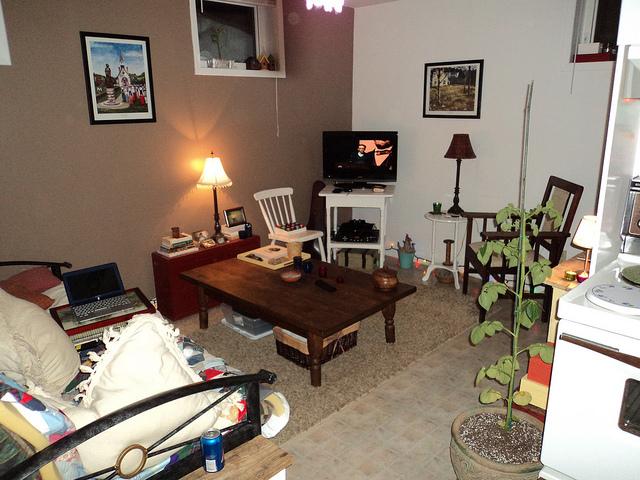How many lamps are on?
Keep it brief. 1. Is this a big room?
Answer briefly. No. Is there a plant inside the room?
Answer briefly. Yes. 